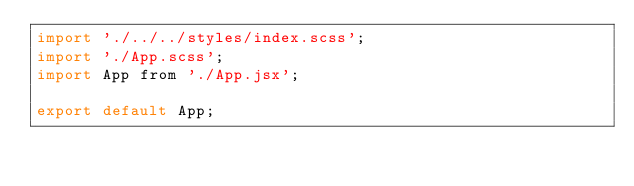Convert code to text. <code><loc_0><loc_0><loc_500><loc_500><_JavaScript_>import './../../styles/index.scss';
import './App.scss';
import App from './App.jsx';

export default App;
</code> 